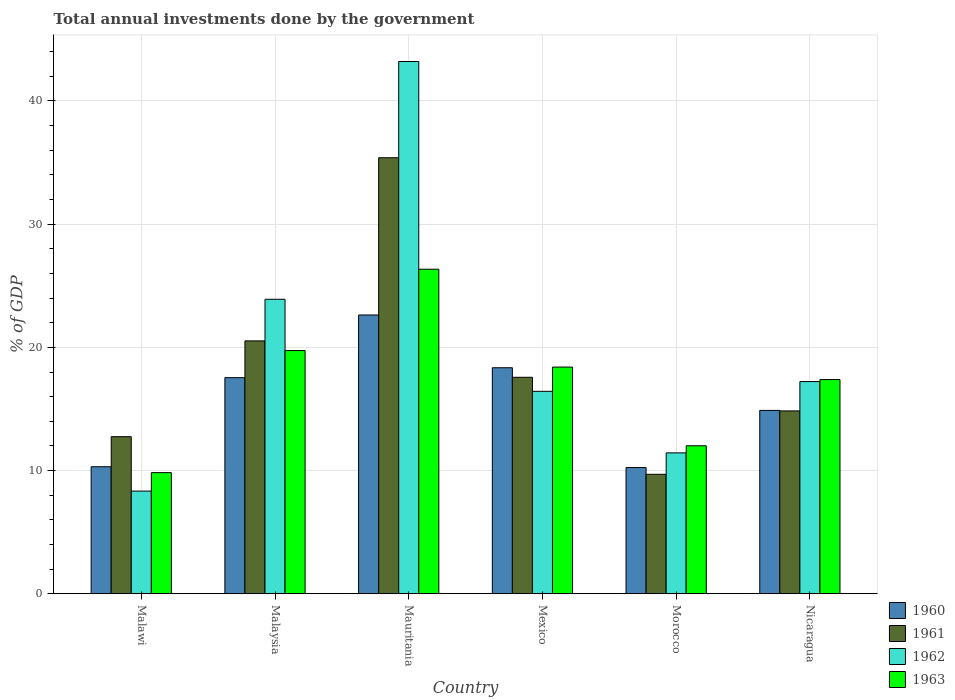How many different coloured bars are there?
Keep it short and to the point. 4. How many groups of bars are there?
Your response must be concise. 6. How many bars are there on the 5th tick from the right?
Provide a succinct answer. 4. In how many cases, is the number of bars for a given country not equal to the number of legend labels?
Give a very brief answer. 0. What is the total annual investments done by the government in 1960 in Malawi?
Give a very brief answer. 10.31. Across all countries, what is the maximum total annual investments done by the government in 1960?
Ensure brevity in your answer.  22.63. Across all countries, what is the minimum total annual investments done by the government in 1962?
Provide a short and direct response. 8.33. In which country was the total annual investments done by the government in 1961 maximum?
Offer a very short reply. Mauritania. In which country was the total annual investments done by the government in 1963 minimum?
Make the answer very short. Malawi. What is the total total annual investments done by the government in 1961 in the graph?
Offer a very short reply. 110.78. What is the difference between the total annual investments done by the government in 1961 in Mauritania and that in Morocco?
Offer a terse response. 25.7. What is the difference between the total annual investments done by the government in 1961 in Mauritania and the total annual investments done by the government in 1962 in Malaysia?
Keep it short and to the point. 11.49. What is the average total annual investments done by the government in 1963 per country?
Your response must be concise. 17.29. What is the difference between the total annual investments done by the government of/in 1961 and total annual investments done by the government of/in 1963 in Malaysia?
Make the answer very short. 0.78. In how many countries, is the total annual investments done by the government in 1961 greater than 34 %?
Offer a very short reply. 1. What is the ratio of the total annual investments done by the government in 1961 in Malaysia to that in Mauritania?
Your answer should be very brief. 0.58. What is the difference between the highest and the second highest total annual investments done by the government in 1961?
Ensure brevity in your answer.  -17.82. What is the difference between the highest and the lowest total annual investments done by the government in 1961?
Keep it short and to the point. 25.7. In how many countries, is the total annual investments done by the government in 1962 greater than the average total annual investments done by the government in 1962 taken over all countries?
Keep it short and to the point. 2. Is the sum of the total annual investments done by the government in 1960 in Malaysia and Mexico greater than the maximum total annual investments done by the government in 1963 across all countries?
Offer a terse response. Yes. Is it the case that in every country, the sum of the total annual investments done by the government in 1961 and total annual investments done by the government in 1962 is greater than the total annual investments done by the government in 1960?
Ensure brevity in your answer.  Yes. How many bars are there?
Keep it short and to the point. 24. Are all the bars in the graph horizontal?
Your response must be concise. No. What is the difference between two consecutive major ticks on the Y-axis?
Keep it short and to the point. 10. Does the graph contain any zero values?
Provide a short and direct response. No. How are the legend labels stacked?
Make the answer very short. Vertical. What is the title of the graph?
Make the answer very short. Total annual investments done by the government. Does "2013" appear as one of the legend labels in the graph?
Your answer should be compact. No. What is the label or title of the X-axis?
Offer a very short reply. Country. What is the label or title of the Y-axis?
Provide a short and direct response. % of GDP. What is the % of GDP in 1960 in Malawi?
Keep it short and to the point. 10.31. What is the % of GDP of 1961 in Malawi?
Ensure brevity in your answer.  12.75. What is the % of GDP in 1962 in Malawi?
Your response must be concise. 8.33. What is the % of GDP in 1963 in Malawi?
Your answer should be very brief. 9.83. What is the % of GDP in 1960 in Malaysia?
Keep it short and to the point. 17.54. What is the % of GDP in 1961 in Malaysia?
Your response must be concise. 20.52. What is the % of GDP in 1962 in Malaysia?
Your response must be concise. 23.9. What is the % of GDP of 1963 in Malaysia?
Provide a succinct answer. 19.74. What is the % of GDP in 1960 in Mauritania?
Give a very brief answer. 22.63. What is the % of GDP of 1961 in Mauritania?
Offer a terse response. 35.39. What is the % of GDP of 1962 in Mauritania?
Your response must be concise. 43.21. What is the % of GDP of 1963 in Mauritania?
Your answer should be very brief. 26.34. What is the % of GDP in 1960 in Mexico?
Ensure brevity in your answer.  18.35. What is the % of GDP in 1961 in Mexico?
Make the answer very short. 17.57. What is the % of GDP of 1962 in Mexico?
Give a very brief answer. 16.43. What is the % of GDP of 1963 in Mexico?
Offer a very short reply. 18.4. What is the % of GDP in 1960 in Morocco?
Keep it short and to the point. 10.24. What is the % of GDP of 1961 in Morocco?
Your answer should be compact. 9.7. What is the % of GDP of 1962 in Morocco?
Give a very brief answer. 11.43. What is the % of GDP of 1963 in Morocco?
Ensure brevity in your answer.  12.01. What is the % of GDP in 1960 in Nicaragua?
Offer a terse response. 14.88. What is the % of GDP in 1961 in Nicaragua?
Make the answer very short. 14.84. What is the % of GDP in 1962 in Nicaragua?
Your answer should be compact. 17.22. What is the % of GDP of 1963 in Nicaragua?
Provide a succinct answer. 17.39. Across all countries, what is the maximum % of GDP in 1960?
Keep it short and to the point. 22.63. Across all countries, what is the maximum % of GDP of 1961?
Offer a very short reply. 35.39. Across all countries, what is the maximum % of GDP in 1962?
Your answer should be very brief. 43.21. Across all countries, what is the maximum % of GDP of 1963?
Your response must be concise. 26.34. Across all countries, what is the minimum % of GDP in 1960?
Offer a terse response. 10.24. Across all countries, what is the minimum % of GDP of 1961?
Provide a succinct answer. 9.7. Across all countries, what is the minimum % of GDP in 1962?
Keep it short and to the point. 8.33. Across all countries, what is the minimum % of GDP of 1963?
Give a very brief answer. 9.83. What is the total % of GDP of 1960 in the graph?
Ensure brevity in your answer.  93.95. What is the total % of GDP of 1961 in the graph?
Keep it short and to the point. 110.78. What is the total % of GDP in 1962 in the graph?
Your answer should be very brief. 120.53. What is the total % of GDP in 1963 in the graph?
Keep it short and to the point. 103.71. What is the difference between the % of GDP of 1960 in Malawi and that in Malaysia?
Your answer should be compact. -7.23. What is the difference between the % of GDP in 1961 in Malawi and that in Malaysia?
Provide a succinct answer. -7.77. What is the difference between the % of GDP in 1962 in Malawi and that in Malaysia?
Your response must be concise. -15.57. What is the difference between the % of GDP in 1963 in Malawi and that in Malaysia?
Offer a very short reply. -9.91. What is the difference between the % of GDP in 1960 in Malawi and that in Mauritania?
Provide a succinct answer. -12.32. What is the difference between the % of GDP in 1961 in Malawi and that in Mauritania?
Your answer should be very brief. -22.64. What is the difference between the % of GDP of 1962 in Malawi and that in Mauritania?
Give a very brief answer. -34.87. What is the difference between the % of GDP in 1963 in Malawi and that in Mauritania?
Make the answer very short. -16.51. What is the difference between the % of GDP in 1960 in Malawi and that in Mexico?
Ensure brevity in your answer.  -8.04. What is the difference between the % of GDP in 1961 in Malawi and that in Mexico?
Give a very brief answer. -4.82. What is the difference between the % of GDP of 1962 in Malawi and that in Mexico?
Offer a very short reply. -8.1. What is the difference between the % of GDP of 1963 in Malawi and that in Mexico?
Your answer should be very brief. -8.57. What is the difference between the % of GDP of 1960 in Malawi and that in Morocco?
Offer a very short reply. 0.07. What is the difference between the % of GDP in 1961 in Malawi and that in Morocco?
Offer a terse response. 3.06. What is the difference between the % of GDP of 1962 in Malawi and that in Morocco?
Your answer should be compact. -3.1. What is the difference between the % of GDP of 1963 in Malawi and that in Morocco?
Your answer should be very brief. -2.18. What is the difference between the % of GDP of 1960 in Malawi and that in Nicaragua?
Your answer should be compact. -4.57. What is the difference between the % of GDP of 1961 in Malawi and that in Nicaragua?
Your response must be concise. -2.09. What is the difference between the % of GDP in 1962 in Malawi and that in Nicaragua?
Your answer should be very brief. -8.89. What is the difference between the % of GDP of 1963 in Malawi and that in Nicaragua?
Offer a very short reply. -7.56. What is the difference between the % of GDP in 1960 in Malaysia and that in Mauritania?
Make the answer very short. -5.09. What is the difference between the % of GDP in 1961 in Malaysia and that in Mauritania?
Your answer should be very brief. -14.87. What is the difference between the % of GDP in 1962 in Malaysia and that in Mauritania?
Your answer should be very brief. -19.3. What is the difference between the % of GDP in 1963 in Malaysia and that in Mauritania?
Your response must be concise. -6.6. What is the difference between the % of GDP of 1960 in Malaysia and that in Mexico?
Your answer should be compact. -0.8. What is the difference between the % of GDP in 1961 in Malaysia and that in Mexico?
Provide a short and direct response. 2.95. What is the difference between the % of GDP of 1962 in Malaysia and that in Mexico?
Your response must be concise. 7.47. What is the difference between the % of GDP of 1963 in Malaysia and that in Mexico?
Offer a terse response. 1.34. What is the difference between the % of GDP of 1960 in Malaysia and that in Morocco?
Provide a short and direct response. 7.3. What is the difference between the % of GDP in 1961 in Malaysia and that in Morocco?
Give a very brief answer. 10.83. What is the difference between the % of GDP in 1962 in Malaysia and that in Morocco?
Keep it short and to the point. 12.47. What is the difference between the % of GDP of 1963 in Malaysia and that in Morocco?
Provide a succinct answer. 7.73. What is the difference between the % of GDP in 1960 in Malaysia and that in Nicaragua?
Offer a terse response. 2.66. What is the difference between the % of GDP in 1961 in Malaysia and that in Nicaragua?
Your answer should be compact. 5.68. What is the difference between the % of GDP in 1962 in Malaysia and that in Nicaragua?
Offer a terse response. 6.68. What is the difference between the % of GDP of 1963 in Malaysia and that in Nicaragua?
Ensure brevity in your answer.  2.35. What is the difference between the % of GDP in 1960 in Mauritania and that in Mexico?
Your answer should be compact. 4.28. What is the difference between the % of GDP of 1961 in Mauritania and that in Mexico?
Provide a succinct answer. 17.82. What is the difference between the % of GDP of 1962 in Mauritania and that in Mexico?
Keep it short and to the point. 26.77. What is the difference between the % of GDP in 1963 in Mauritania and that in Mexico?
Your answer should be very brief. 7.94. What is the difference between the % of GDP in 1960 in Mauritania and that in Morocco?
Ensure brevity in your answer.  12.38. What is the difference between the % of GDP of 1961 in Mauritania and that in Morocco?
Offer a very short reply. 25.7. What is the difference between the % of GDP of 1962 in Mauritania and that in Morocco?
Ensure brevity in your answer.  31.77. What is the difference between the % of GDP in 1963 in Mauritania and that in Morocco?
Give a very brief answer. 14.33. What is the difference between the % of GDP in 1960 in Mauritania and that in Nicaragua?
Give a very brief answer. 7.74. What is the difference between the % of GDP of 1961 in Mauritania and that in Nicaragua?
Ensure brevity in your answer.  20.55. What is the difference between the % of GDP of 1962 in Mauritania and that in Nicaragua?
Keep it short and to the point. 25.98. What is the difference between the % of GDP of 1963 in Mauritania and that in Nicaragua?
Offer a very short reply. 8.96. What is the difference between the % of GDP of 1960 in Mexico and that in Morocco?
Provide a succinct answer. 8.1. What is the difference between the % of GDP in 1961 in Mexico and that in Morocco?
Your response must be concise. 7.88. What is the difference between the % of GDP of 1962 in Mexico and that in Morocco?
Keep it short and to the point. 5. What is the difference between the % of GDP of 1963 in Mexico and that in Morocco?
Your answer should be compact. 6.39. What is the difference between the % of GDP of 1960 in Mexico and that in Nicaragua?
Provide a short and direct response. 3.46. What is the difference between the % of GDP of 1961 in Mexico and that in Nicaragua?
Your answer should be very brief. 2.73. What is the difference between the % of GDP of 1962 in Mexico and that in Nicaragua?
Make the answer very short. -0.79. What is the difference between the % of GDP in 1963 in Mexico and that in Nicaragua?
Offer a very short reply. 1.01. What is the difference between the % of GDP in 1960 in Morocco and that in Nicaragua?
Offer a terse response. -4.64. What is the difference between the % of GDP in 1961 in Morocco and that in Nicaragua?
Provide a succinct answer. -5.15. What is the difference between the % of GDP in 1962 in Morocco and that in Nicaragua?
Offer a terse response. -5.79. What is the difference between the % of GDP in 1963 in Morocco and that in Nicaragua?
Offer a terse response. -5.38. What is the difference between the % of GDP of 1960 in Malawi and the % of GDP of 1961 in Malaysia?
Keep it short and to the point. -10.22. What is the difference between the % of GDP of 1960 in Malawi and the % of GDP of 1962 in Malaysia?
Your answer should be very brief. -13.59. What is the difference between the % of GDP of 1960 in Malawi and the % of GDP of 1963 in Malaysia?
Provide a succinct answer. -9.43. What is the difference between the % of GDP of 1961 in Malawi and the % of GDP of 1962 in Malaysia?
Your answer should be compact. -11.15. What is the difference between the % of GDP in 1961 in Malawi and the % of GDP in 1963 in Malaysia?
Give a very brief answer. -6.99. What is the difference between the % of GDP in 1962 in Malawi and the % of GDP in 1963 in Malaysia?
Make the answer very short. -11.41. What is the difference between the % of GDP in 1960 in Malawi and the % of GDP in 1961 in Mauritania?
Your response must be concise. -25.08. What is the difference between the % of GDP of 1960 in Malawi and the % of GDP of 1962 in Mauritania?
Make the answer very short. -32.9. What is the difference between the % of GDP in 1960 in Malawi and the % of GDP in 1963 in Mauritania?
Offer a terse response. -16.03. What is the difference between the % of GDP in 1961 in Malawi and the % of GDP in 1962 in Mauritania?
Your response must be concise. -30.46. What is the difference between the % of GDP of 1961 in Malawi and the % of GDP of 1963 in Mauritania?
Give a very brief answer. -13.59. What is the difference between the % of GDP in 1962 in Malawi and the % of GDP in 1963 in Mauritania?
Give a very brief answer. -18.01. What is the difference between the % of GDP of 1960 in Malawi and the % of GDP of 1961 in Mexico?
Provide a succinct answer. -7.26. What is the difference between the % of GDP of 1960 in Malawi and the % of GDP of 1962 in Mexico?
Your response must be concise. -6.12. What is the difference between the % of GDP in 1960 in Malawi and the % of GDP in 1963 in Mexico?
Offer a very short reply. -8.09. What is the difference between the % of GDP of 1961 in Malawi and the % of GDP of 1962 in Mexico?
Your answer should be compact. -3.68. What is the difference between the % of GDP of 1961 in Malawi and the % of GDP of 1963 in Mexico?
Ensure brevity in your answer.  -5.65. What is the difference between the % of GDP of 1962 in Malawi and the % of GDP of 1963 in Mexico?
Ensure brevity in your answer.  -10.07. What is the difference between the % of GDP in 1960 in Malawi and the % of GDP in 1961 in Morocco?
Your answer should be compact. 0.61. What is the difference between the % of GDP of 1960 in Malawi and the % of GDP of 1962 in Morocco?
Your answer should be very brief. -1.13. What is the difference between the % of GDP of 1960 in Malawi and the % of GDP of 1963 in Morocco?
Provide a succinct answer. -1.7. What is the difference between the % of GDP in 1961 in Malawi and the % of GDP in 1962 in Morocco?
Keep it short and to the point. 1.32. What is the difference between the % of GDP of 1961 in Malawi and the % of GDP of 1963 in Morocco?
Provide a succinct answer. 0.74. What is the difference between the % of GDP of 1962 in Malawi and the % of GDP of 1963 in Morocco?
Keep it short and to the point. -3.68. What is the difference between the % of GDP of 1960 in Malawi and the % of GDP of 1961 in Nicaragua?
Your answer should be compact. -4.53. What is the difference between the % of GDP of 1960 in Malawi and the % of GDP of 1962 in Nicaragua?
Offer a very short reply. -6.91. What is the difference between the % of GDP in 1960 in Malawi and the % of GDP in 1963 in Nicaragua?
Make the answer very short. -7.08. What is the difference between the % of GDP of 1961 in Malawi and the % of GDP of 1962 in Nicaragua?
Offer a terse response. -4.47. What is the difference between the % of GDP of 1961 in Malawi and the % of GDP of 1963 in Nicaragua?
Ensure brevity in your answer.  -4.64. What is the difference between the % of GDP of 1962 in Malawi and the % of GDP of 1963 in Nicaragua?
Make the answer very short. -9.05. What is the difference between the % of GDP in 1960 in Malaysia and the % of GDP in 1961 in Mauritania?
Ensure brevity in your answer.  -17.85. What is the difference between the % of GDP in 1960 in Malaysia and the % of GDP in 1962 in Mauritania?
Provide a short and direct response. -25.67. What is the difference between the % of GDP in 1960 in Malaysia and the % of GDP in 1963 in Mauritania?
Your answer should be very brief. -8.8. What is the difference between the % of GDP of 1961 in Malaysia and the % of GDP of 1962 in Mauritania?
Make the answer very short. -22.68. What is the difference between the % of GDP in 1961 in Malaysia and the % of GDP in 1963 in Mauritania?
Offer a very short reply. -5.82. What is the difference between the % of GDP of 1962 in Malaysia and the % of GDP of 1963 in Mauritania?
Ensure brevity in your answer.  -2.44. What is the difference between the % of GDP in 1960 in Malaysia and the % of GDP in 1961 in Mexico?
Ensure brevity in your answer.  -0.03. What is the difference between the % of GDP of 1960 in Malaysia and the % of GDP of 1962 in Mexico?
Your response must be concise. 1.11. What is the difference between the % of GDP in 1960 in Malaysia and the % of GDP in 1963 in Mexico?
Make the answer very short. -0.86. What is the difference between the % of GDP of 1961 in Malaysia and the % of GDP of 1962 in Mexico?
Your answer should be compact. 4.09. What is the difference between the % of GDP of 1961 in Malaysia and the % of GDP of 1963 in Mexico?
Offer a terse response. 2.13. What is the difference between the % of GDP in 1962 in Malaysia and the % of GDP in 1963 in Mexico?
Provide a succinct answer. 5.5. What is the difference between the % of GDP in 1960 in Malaysia and the % of GDP in 1961 in Morocco?
Your answer should be compact. 7.85. What is the difference between the % of GDP in 1960 in Malaysia and the % of GDP in 1962 in Morocco?
Make the answer very short. 6.11. What is the difference between the % of GDP of 1960 in Malaysia and the % of GDP of 1963 in Morocco?
Your answer should be very brief. 5.53. What is the difference between the % of GDP of 1961 in Malaysia and the % of GDP of 1962 in Morocco?
Give a very brief answer. 9.09. What is the difference between the % of GDP of 1961 in Malaysia and the % of GDP of 1963 in Morocco?
Provide a succinct answer. 8.51. What is the difference between the % of GDP in 1962 in Malaysia and the % of GDP in 1963 in Morocco?
Your answer should be compact. 11.89. What is the difference between the % of GDP of 1960 in Malaysia and the % of GDP of 1961 in Nicaragua?
Provide a short and direct response. 2.7. What is the difference between the % of GDP in 1960 in Malaysia and the % of GDP in 1962 in Nicaragua?
Ensure brevity in your answer.  0.32. What is the difference between the % of GDP in 1960 in Malaysia and the % of GDP in 1963 in Nicaragua?
Your answer should be very brief. 0.15. What is the difference between the % of GDP in 1961 in Malaysia and the % of GDP in 1962 in Nicaragua?
Offer a very short reply. 3.3. What is the difference between the % of GDP in 1961 in Malaysia and the % of GDP in 1963 in Nicaragua?
Your response must be concise. 3.14. What is the difference between the % of GDP in 1962 in Malaysia and the % of GDP in 1963 in Nicaragua?
Give a very brief answer. 6.52. What is the difference between the % of GDP of 1960 in Mauritania and the % of GDP of 1961 in Mexico?
Ensure brevity in your answer.  5.06. What is the difference between the % of GDP in 1960 in Mauritania and the % of GDP in 1962 in Mexico?
Offer a very short reply. 6.2. What is the difference between the % of GDP in 1960 in Mauritania and the % of GDP in 1963 in Mexico?
Make the answer very short. 4.23. What is the difference between the % of GDP in 1961 in Mauritania and the % of GDP in 1962 in Mexico?
Offer a very short reply. 18.96. What is the difference between the % of GDP in 1961 in Mauritania and the % of GDP in 1963 in Mexico?
Ensure brevity in your answer.  16.99. What is the difference between the % of GDP in 1962 in Mauritania and the % of GDP in 1963 in Mexico?
Make the answer very short. 24.81. What is the difference between the % of GDP of 1960 in Mauritania and the % of GDP of 1961 in Morocco?
Ensure brevity in your answer.  12.93. What is the difference between the % of GDP in 1960 in Mauritania and the % of GDP in 1962 in Morocco?
Make the answer very short. 11.19. What is the difference between the % of GDP in 1960 in Mauritania and the % of GDP in 1963 in Morocco?
Make the answer very short. 10.62. What is the difference between the % of GDP in 1961 in Mauritania and the % of GDP in 1962 in Morocco?
Make the answer very short. 23.96. What is the difference between the % of GDP of 1961 in Mauritania and the % of GDP of 1963 in Morocco?
Offer a very short reply. 23.38. What is the difference between the % of GDP of 1962 in Mauritania and the % of GDP of 1963 in Morocco?
Keep it short and to the point. 31.2. What is the difference between the % of GDP in 1960 in Mauritania and the % of GDP in 1961 in Nicaragua?
Provide a succinct answer. 7.79. What is the difference between the % of GDP in 1960 in Mauritania and the % of GDP in 1962 in Nicaragua?
Provide a succinct answer. 5.4. What is the difference between the % of GDP in 1960 in Mauritania and the % of GDP in 1963 in Nicaragua?
Keep it short and to the point. 5.24. What is the difference between the % of GDP in 1961 in Mauritania and the % of GDP in 1962 in Nicaragua?
Give a very brief answer. 18.17. What is the difference between the % of GDP in 1961 in Mauritania and the % of GDP in 1963 in Nicaragua?
Provide a short and direct response. 18.01. What is the difference between the % of GDP in 1962 in Mauritania and the % of GDP in 1963 in Nicaragua?
Make the answer very short. 25.82. What is the difference between the % of GDP in 1960 in Mexico and the % of GDP in 1961 in Morocco?
Offer a terse response. 8.65. What is the difference between the % of GDP of 1960 in Mexico and the % of GDP of 1962 in Morocco?
Provide a short and direct response. 6.91. What is the difference between the % of GDP of 1960 in Mexico and the % of GDP of 1963 in Morocco?
Ensure brevity in your answer.  6.34. What is the difference between the % of GDP of 1961 in Mexico and the % of GDP of 1962 in Morocco?
Make the answer very short. 6.14. What is the difference between the % of GDP of 1961 in Mexico and the % of GDP of 1963 in Morocco?
Your answer should be compact. 5.56. What is the difference between the % of GDP of 1962 in Mexico and the % of GDP of 1963 in Morocco?
Your answer should be very brief. 4.42. What is the difference between the % of GDP in 1960 in Mexico and the % of GDP in 1961 in Nicaragua?
Offer a very short reply. 3.5. What is the difference between the % of GDP of 1960 in Mexico and the % of GDP of 1962 in Nicaragua?
Ensure brevity in your answer.  1.12. What is the difference between the % of GDP of 1960 in Mexico and the % of GDP of 1963 in Nicaragua?
Provide a succinct answer. 0.96. What is the difference between the % of GDP of 1961 in Mexico and the % of GDP of 1962 in Nicaragua?
Keep it short and to the point. 0.35. What is the difference between the % of GDP of 1961 in Mexico and the % of GDP of 1963 in Nicaragua?
Make the answer very short. 0.18. What is the difference between the % of GDP of 1962 in Mexico and the % of GDP of 1963 in Nicaragua?
Your response must be concise. -0.95. What is the difference between the % of GDP in 1960 in Morocco and the % of GDP in 1961 in Nicaragua?
Make the answer very short. -4.6. What is the difference between the % of GDP in 1960 in Morocco and the % of GDP in 1962 in Nicaragua?
Provide a short and direct response. -6.98. What is the difference between the % of GDP of 1960 in Morocco and the % of GDP of 1963 in Nicaragua?
Keep it short and to the point. -7.14. What is the difference between the % of GDP of 1961 in Morocco and the % of GDP of 1962 in Nicaragua?
Your response must be concise. -7.53. What is the difference between the % of GDP in 1961 in Morocco and the % of GDP in 1963 in Nicaragua?
Your response must be concise. -7.69. What is the difference between the % of GDP in 1962 in Morocco and the % of GDP in 1963 in Nicaragua?
Ensure brevity in your answer.  -5.95. What is the average % of GDP of 1960 per country?
Provide a short and direct response. 15.66. What is the average % of GDP of 1961 per country?
Keep it short and to the point. 18.46. What is the average % of GDP in 1962 per country?
Give a very brief answer. 20.09. What is the average % of GDP in 1963 per country?
Provide a succinct answer. 17.29. What is the difference between the % of GDP in 1960 and % of GDP in 1961 in Malawi?
Your answer should be compact. -2.44. What is the difference between the % of GDP of 1960 and % of GDP of 1962 in Malawi?
Your answer should be very brief. 1.98. What is the difference between the % of GDP in 1960 and % of GDP in 1963 in Malawi?
Your answer should be compact. 0.48. What is the difference between the % of GDP in 1961 and % of GDP in 1962 in Malawi?
Keep it short and to the point. 4.42. What is the difference between the % of GDP of 1961 and % of GDP of 1963 in Malawi?
Provide a short and direct response. 2.92. What is the difference between the % of GDP of 1962 and % of GDP of 1963 in Malawi?
Provide a succinct answer. -1.5. What is the difference between the % of GDP of 1960 and % of GDP of 1961 in Malaysia?
Give a very brief answer. -2.98. What is the difference between the % of GDP of 1960 and % of GDP of 1962 in Malaysia?
Provide a succinct answer. -6.36. What is the difference between the % of GDP of 1960 and % of GDP of 1963 in Malaysia?
Give a very brief answer. -2.2. What is the difference between the % of GDP in 1961 and % of GDP in 1962 in Malaysia?
Give a very brief answer. -3.38. What is the difference between the % of GDP in 1961 and % of GDP in 1963 in Malaysia?
Your response must be concise. 0.78. What is the difference between the % of GDP in 1962 and % of GDP in 1963 in Malaysia?
Your response must be concise. 4.16. What is the difference between the % of GDP in 1960 and % of GDP in 1961 in Mauritania?
Make the answer very short. -12.77. What is the difference between the % of GDP of 1960 and % of GDP of 1962 in Mauritania?
Your response must be concise. -20.58. What is the difference between the % of GDP in 1960 and % of GDP in 1963 in Mauritania?
Keep it short and to the point. -3.72. What is the difference between the % of GDP of 1961 and % of GDP of 1962 in Mauritania?
Keep it short and to the point. -7.81. What is the difference between the % of GDP in 1961 and % of GDP in 1963 in Mauritania?
Offer a terse response. 9.05. What is the difference between the % of GDP of 1962 and % of GDP of 1963 in Mauritania?
Keep it short and to the point. 16.86. What is the difference between the % of GDP in 1960 and % of GDP in 1961 in Mexico?
Offer a very short reply. 0.77. What is the difference between the % of GDP in 1960 and % of GDP in 1962 in Mexico?
Your response must be concise. 1.91. What is the difference between the % of GDP of 1960 and % of GDP of 1963 in Mexico?
Provide a succinct answer. -0.05. What is the difference between the % of GDP in 1961 and % of GDP in 1962 in Mexico?
Your answer should be very brief. 1.14. What is the difference between the % of GDP in 1961 and % of GDP in 1963 in Mexico?
Provide a succinct answer. -0.83. What is the difference between the % of GDP in 1962 and % of GDP in 1963 in Mexico?
Provide a succinct answer. -1.97. What is the difference between the % of GDP in 1960 and % of GDP in 1961 in Morocco?
Your response must be concise. 0.55. What is the difference between the % of GDP in 1960 and % of GDP in 1962 in Morocco?
Provide a succinct answer. -1.19. What is the difference between the % of GDP of 1960 and % of GDP of 1963 in Morocco?
Your answer should be compact. -1.77. What is the difference between the % of GDP in 1961 and % of GDP in 1962 in Morocco?
Make the answer very short. -1.74. What is the difference between the % of GDP of 1961 and % of GDP of 1963 in Morocco?
Offer a very short reply. -2.32. What is the difference between the % of GDP in 1962 and % of GDP in 1963 in Morocco?
Provide a short and direct response. -0.58. What is the difference between the % of GDP of 1960 and % of GDP of 1961 in Nicaragua?
Provide a succinct answer. 0.04. What is the difference between the % of GDP in 1960 and % of GDP in 1962 in Nicaragua?
Provide a succinct answer. -2.34. What is the difference between the % of GDP in 1960 and % of GDP in 1963 in Nicaragua?
Provide a succinct answer. -2.5. What is the difference between the % of GDP of 1961 and % of GDP of 1962 in Nicaragua?
Your answer should be compact. -2.38. What is the difference between the % of GDP of 1961 and % of GDP of 1963 in Nicaragua?
Your response must be concise. -2.55. What is the difference between the % of GDP of 1962 and % of GDP of 1963 in Nicaragua?
Make the answer very short. -0.16. What is the ratio of the % of GDP of 1960 in Malawi to that in Malaysia?
Provide a succinct answer. 0.59. What is the ratio of the % of GDP in 1961 in Malawi to that in Malaysia?
Offer a terse response. 0.62. What is the ratio of the % of GDP of 1962 in Malawi to that in Malaysia?
Ensure brevity in your answer.  0.35. What is the ratio of the % of GDP in 1963 in Malawi to that in Malaysia?
Make the answer very short. 0.5. What is the ratio of the % of GDP in 1960 in Malawi to that in Mauritania?
Ensure brevity in your answer.  0.46. What is the ratio of the % of GDP in 1961 in Malawi to that in Mauritania?
Offer a terse response. 0.36. What is the ratio of the % of GDP of 1962 in Malawi to that in Mauritania?
Your answer should be compact. 0.19. What is the ratio of the % of GDP in 1963 in Malawi to that in Mauritania?
Provide a succinct answer. 0.37. What is the ratio of the % of GDP of 1960 in Malawi to that in Mexico?
Offer a terse response. 0.56. What is the ratio of the % of GDP of 1961 in Malawi to that in Mexico?
Your answer should be compact. 0.73. What is the ratio of the % of GDP in 1962 in Malawi to that in Mexico?
Give a very brief answer. 0.51. What is the ratio of the % of GDP of 1963 in Malawi to that in Mexico?
Your response must be concise. 0.53. What is the ratio of the % of GDP in 1960 in Malawi to that in Morocco?
Your response must be concise. 1.01. What is the ratio of the % of GDP in 1961 in Malawi to that in Morocco?
Provide a short and direct response. 1.32. What is the ratio of the % of GDP in 1962 in Malawi to that in Morocco?
Make the answer very short. 0.73. What is the ratio of the % of GDP in 1963 in Malawi to that in Morocco?
Ensure brevity in your answer.  0.82. What is the ratio of the % of GDP of 1960 in Malawi to that in Nicaragua?
Provide a succinct answer. 0.69. What is the ratio of the % of GDP of 1961 in Malawi to that in Nicaragua?
Make the answer very short. 0.86. What is the ratio of the % of GDP of 1962 in Malawi to that in Nicaragua?
Offer a terse response. 0.48. What is the ratio of the % of GDP in 1963 in Malawi to that in Nicaragua?
Provide a short and direct response. 0.57. What is the ratio of the % of GDP of 1960 in Malaysia to that in Mauritania?
Your answer should be very brief. 0.78. What is the ratio of the % of GDP in 1961 in Malaysia to that in Mauritania?
Your answer should be compact. 0.58. What is the ratio of the % of GDP in 1962 in Malaysia to that in Mauritania?
Offer a terse response. 0.55. What is the ratio of the % of GDP in 1963 in Malaysia to that in Mauritania?
Provide a short and direct response. 0.75. What is the ratio of the % of GDP of 1960 in Malaysia to that in Mexico?
Your response must be concise. 0.96. What is the ratio of the % of GDP in 1961 in Malaysia to that in Mexico?
Your answer should be compact. 1.17. What is the ratio of the % of GDP in 1962 in Malaysia to that in Mexico?
Make the answer very short. 1.45. What is the ratio of the % of GDP of 1963 in Malaysia to that in Mexico?
Provide a short and direct response. 1.07. What is the ratio of the % of GDP of 1960 in Malaysia to that in Morocco?
Ensure brevity in your answer.  1.71. What is the ratio of the % of GDP in 1961 in Malaysia to that in Morocco?
Your answer should be very brief. 2.12. What is the ratio of the % of GDP of 1962 in Malaysia to that in Morocco?
Offer a very short reply. 2.09. What is the ratio of the % of GDP of 1963 in Malaysia to that in Morocco?
Provide a short and direct response. 1.64. What is the ratio of the % of GDP in 1960 in Malaysia to that in Nicaragua?
Keep it short and to the point. 1.18. What is the ratio of the % of GDP of 1961 in Malaysia to that in Nicaragua?
Provide a succinct answer. 1.38. What is the ratio of the % of GDP of 1962 in Malaysia to that in Nicaragua?
Ensure brevity in your answer.  1.39. What is the ratio of the % of GDP of 1963 in Malaysia to that in Nicaragua?
Your answer should be very brief. 1.14. What is the ratio of the % of GDP of 1960 in Mauritania to that in Mexico?
Offer a very short reply. 1.23. What is the ratio of the % of GDP in 1961 in Mauritania to that in Mexico?
Your response must be concise. 2.01. What is the ratio of the % of GDP of 1962 in Mauritania to that in Mexico?
Provide a short and direct response. 2.63. What is the ratio of the % of GDP of 1963 in Mauritania to that in Mexico?
Provide a short and direct response. 1.43. What is the ratio of the % of GDP in 1960 in Mauritania to that in Morocco?
Your answer should be very brief. 2.21. What is the ratio of the % of GDP in 1961 in Mauritania to that in Morocco?
Offer a very short reply. 3.65. What is the ratio of the % of GDP in 1962 in Mauritania to that in Morocco?
Make the answer very short. 3.78. What is the ratio of the % of GDP in 1963 in Mauritania to that in Morocco?
Provide a short and direct response. 2.19. What is the ratio of the % of GDP of 1960 in Mauritania to that in Nicaragua?
Provide a short and direct response. 1.52. What is the ratio of the % of GDP in 1961 in Mauritania to that in Nicaragua?
Your answer should be compact. 2.38. What is the ratio of the % of GDP in 1962 in Mauritania to that in Nicaragua?
Make the answer very short. 2.51. What is the ratio of the % of GDP in 1963 in Mauritania to that in Nicaragua?
Make the answer very short. 1.52. What is the ratio of the % of GDP in 1960 in Mexico to that in Morocco?
Your response must be concise. 1.79. What is the ratio of the % of GDP in 1961 in Mexico to that in Morocco?
Your answer should be compact. 1.81. What is the ratio of the % of GDP in 1962 in Mexico to that in Morocco?
Keep it short and to the point. 1.44. What is the ratio of the % of GDP of 1963 in Mexico to that in Morocco?
Keep it short and to the point. 1.53. What is the ratio of the % of GDP in 1960 in Mexico to that in Nicaragua?
Offer a terse response. 1.23. What is the ratio of the % of GDP of 1961 in Mexico to that in Nicaragua?
Your answer should be compact. 1.18. What is the ratio of the % of GDP of 1962 in Mexico to that in Nicaragua?
Provide a short and direct response. 0.95. What is the ratio of the % of GDP of 1963 in Mexico to that in Nicaragua?
Offer a very short reply. 1.06. What is the ratio of the % of GDP of 1960 in Morocco to that in Nicaragua?
Provide a succinct answer. 0.69. What is the ratio of the % of GDP in 1961 in Morocco to that in Nicaragua?
Provide a short and direct response. 0.65. What is the ratio of the % of GDP of 1962 in Morocco to that in Nicaragua?
Provide a short and direct response. 0.66. What is the ratio of the % of GDP of 1963 in Morocco to that in Nicaragua?
Your response must be concise. 0.69. What is the difference between the highest and the second highest % of GDP of 1960?
Give a very brief answer. 4.28. What is the difference between the highest and the second highest % of GDP in 1961?
Offer a very short reply. 14.87. What is the difference between the highest and the second highest % of GDP in 1962?
Make the answer very short. 19.3. What is the difference between the highest and the second highest % of GDP of 1963?
Your answer should be very brief. 6.6. What is the difference between the highest and the lowest % of GDP of 1960?
Give a very brief answer. 12.38. What is the difference between the highest and the lowest % of GDP of 1961?
Provide a short and direct response. 25.7. What is the difference between the highest and the lowest % of GDP in 1962?
Provide a short and direct response. 34.87. What is the difference between the highest and the lowest % of GDP of 1963?
Offer a terse response. 16.51. 